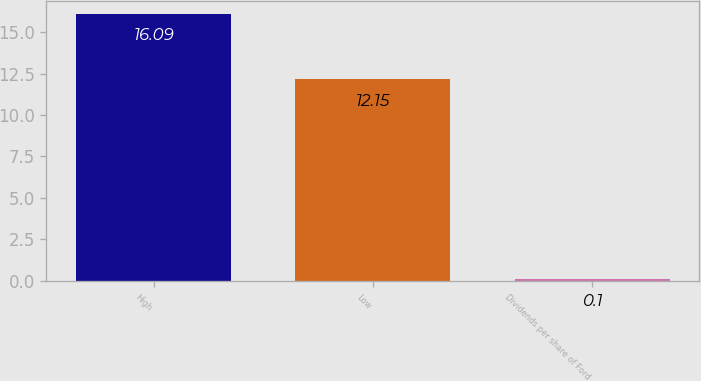Convert chart. <chart><loc_0><loc_0><loc_500><loc_500><bar_chart><fcel>High<fcel>Low<fcel>Dividends per share of Ford<nl><fcel>16.09<fcel>12.15<fcel>0.1<nl></chart> 